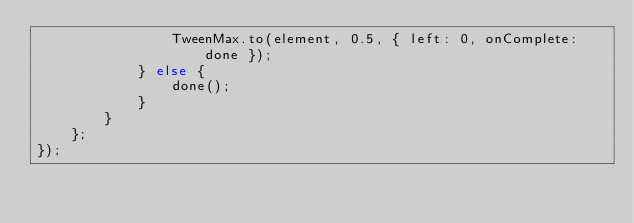Convert code to text. <code><loc_0><loc_0><loc_500><loc_500><_JavaScript_>                TweenMax.to(element, 0.5, { left: 0, onComplete: done });
            } else {
                done();
            }
        }
    };
});
</code> 